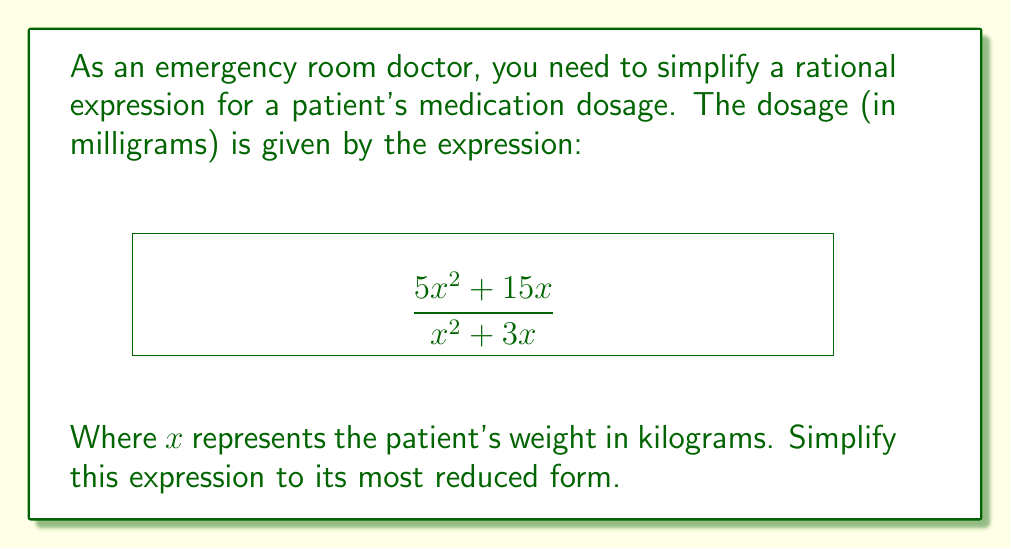Give your solution to this math problem. Let's simplify this rational expression step-by-step:

1) First, we need to factor out the greatest common factor (GCF) from both the numerator and denominator.

   Numerator: $5x^2 + 15x = 5x(x + 3)$
   Denominator: $x^2 + 3x = x(x + 3)$

2) Now our expression looks like this:

   $$\frac{5x(x + 3)}{x(x + 3)}$$

3) We can cancel out the common factor $(x + 3)$ from both the numerator and denominator:

   $$\frac{5x\cancel{(x + 3)}}{x\cancel{(x + 3)}}$$

4) This simplifies to:

   $$\frac{5x}{x}$$

5) Finally, we can cancel out $x$ from both the numerator and denominator:

   $$\frac{5\cancel{x}}{\cancel{x}} = 5$$

Therefore, the simplified expression is 5, which means the dosage is 5 mg per kg of the patient's weight.
Answer: $5$ 